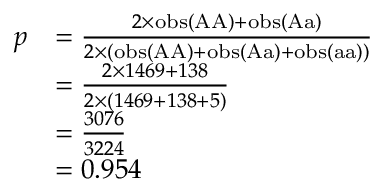<formula> <loc_0><loc_0><loc_500><loc_500>{ \begin{array} { r l } { p } & { = { \frac { 2 \times o b s ( { A A } ) + o b s ( { A a } ) } { 2 \times ( o b s ( { A A } ) + o b s ( { A a } ) + o b s ( { a a } ) ) } } } \\ & { = { \frac { 2 \times 1 4 6 9 + 1 3 8 } { 2 \times ( 1 4 6 9 + 1 3 8 + 5 ) } } } \\ & { = { \frac { 3 0 7 6 } { 3 2 2 4 } } } \\ & { = 0 . 9 5 4 } \end{array} }</formula> 